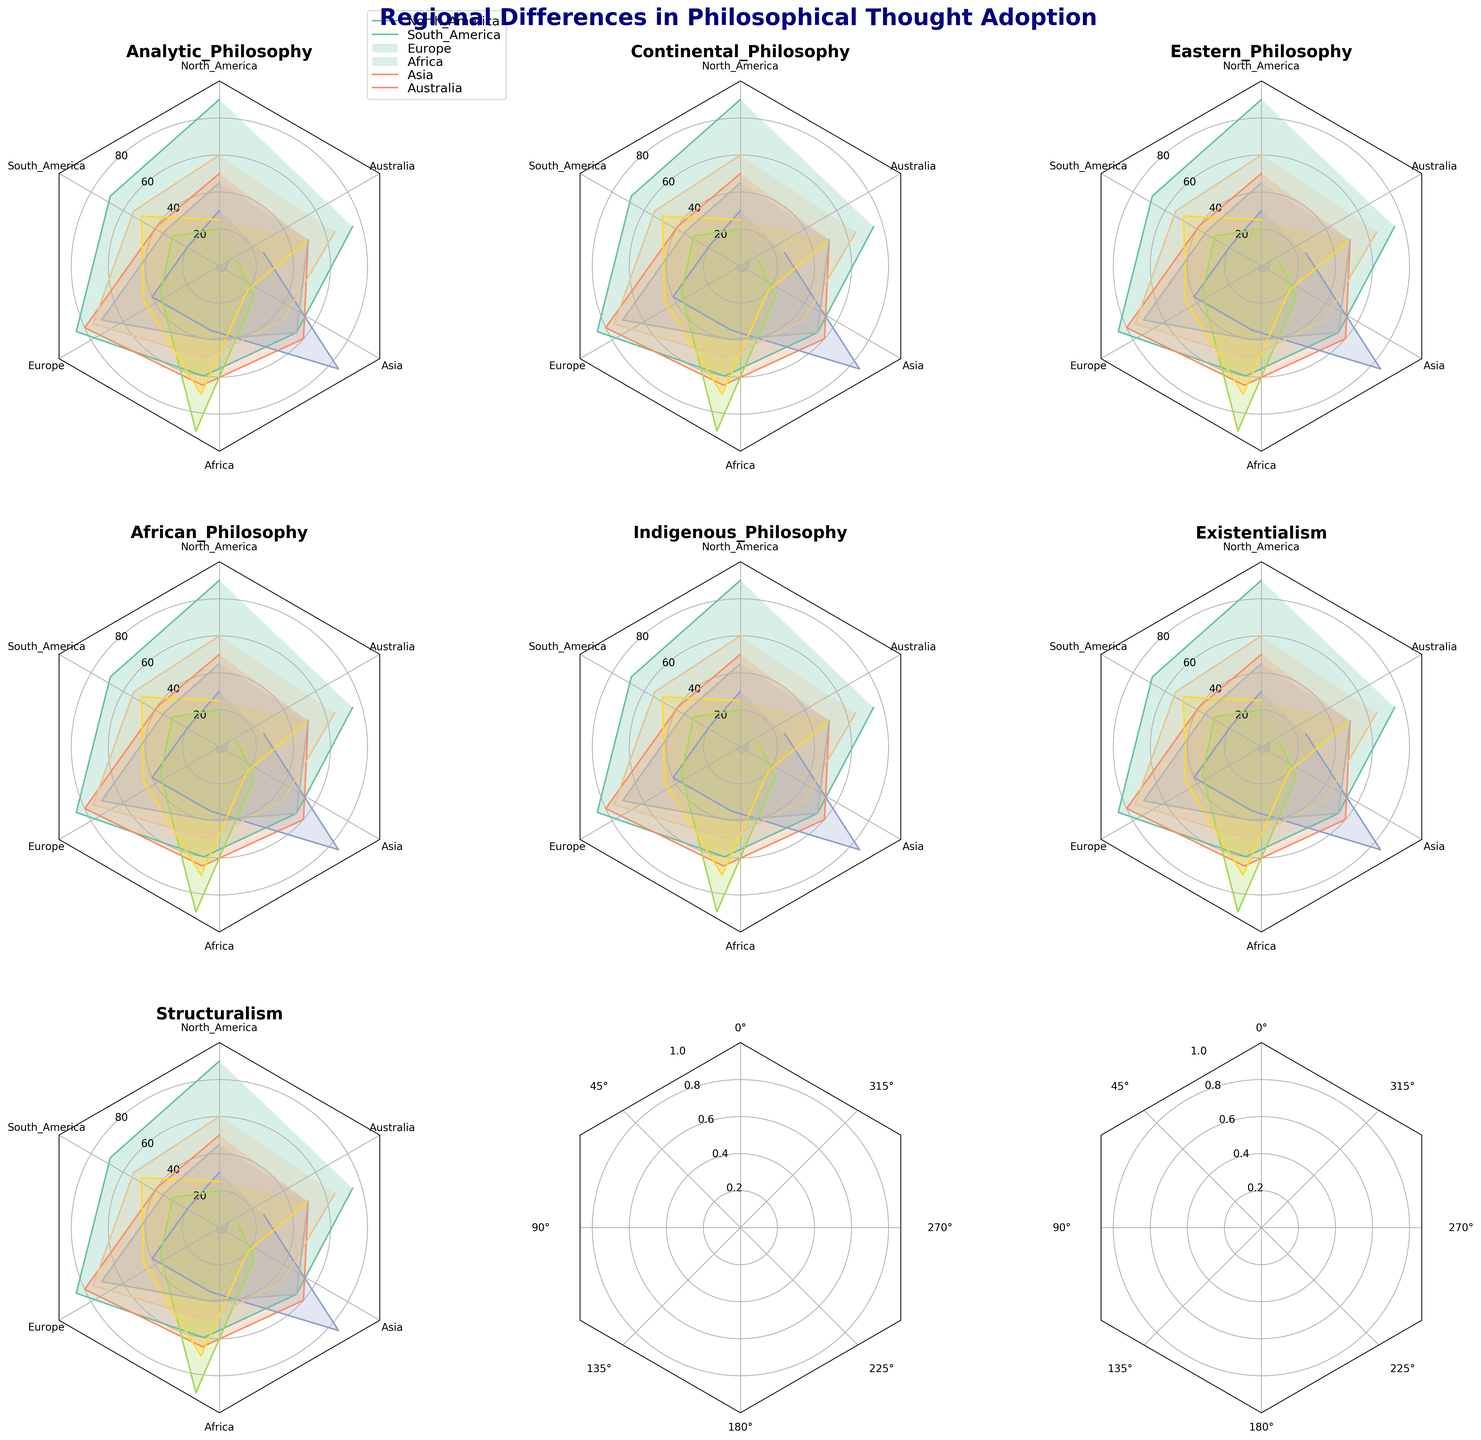Which region has the highest adoption of Analytic Philosophy? By examining the radar chart subplot for Analytic Philosophy, we see the values around the North America axis. The highest value is located in North America with a value of 90.
Answer: North America Which region has the lowest score for African Philosophy? Observing the African Philosophy subplot and looking along each region's axis, Australia has the lowest value, which is 10.
Answer: Australia How do the values of Southern America compare between Indigenous Philosophy and Eastern Philosophy? Looking at the subplots for Indigenous Philosophy and Eastern Philosophy, Southern America scores 50 for Indigenous Philosophy and 20 for Eastern Philosophy. Hence, Indigenous Philosophy has a higher value by 30.
Answer: Indigenous Philosophy is higher by 30 Which philosophical school has the highest adoption in Europe? By examining each subplot and looking at the values for Europe, the highest value observed is for Continental Philosophy, which is 80.
Answer: Continental Philosophy What is the average adoption score of Existentialism across all regions? Add the Existentialism values: 60 (North America), 55 (South America), 75 (Europe), 50 (Africa), 45 (Asia), and 65 (Australia). Sum is 350. Divided by 6 regions, the average score is 350/6 ≈ 58.33.
Answer: 58.33 Which two regions have the highest difference in adoption of Structuralism? Examining the Structuralism subplot, North America has a value of 45 and Europe has the highest value of 70. The difference is 70 - 45 = 25.
Answer: Europe and North America What's the difference between the highest and lowest adoption scores for Eastern Philosophy? Looking at the values for Eastern Philosophy, the highest is 85 (Asia) and the lowest is 20 (South America). The difference is 85 - 20 = 65.
Answer: 65 How does the adoption of Indigenous Philosophy in Australia compare to that in North America? Indigenous Philosophy in Australia has a value of 50, whereas in North America it is 25. The value in Australia is higher by 25.
Answer: Australia is higher by 25 Which philosophical school has the most uniform adoption across all regions? Uniform adoption would mean similar scores across all regions. By examining the subplots, Existentialism shows relatively consistent values: 60, 55, 75, 50, 45, 65.
Answer: Existentialism In which region is the difference between Continental Philosophy and African Philosophy scores the greatest? Looking at the Continental and African Philosophy subplots for each region, Europe has scores of 80 for Continental and 35 for African Philosophy. The difference is 80 - 35 = 45, the greatest difference among the regions.
Answer: Europe 